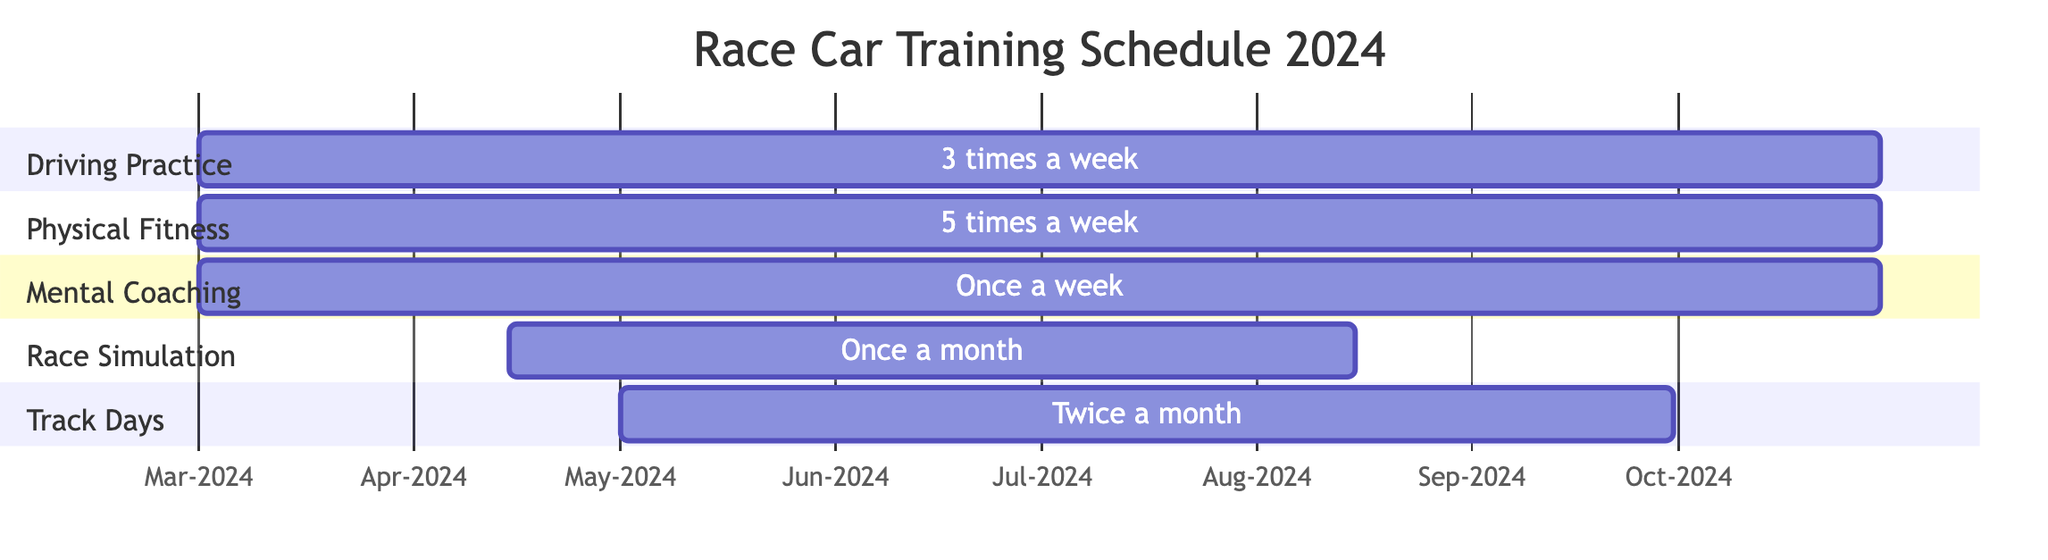What is the duration of the Driving Practice? The duration of Driving Practice is given in the diagram as 245 days. This is stated directly under the Driving Practice section.
Answer: 245 days How many times a week is Physical Fitness Training scheduled? The frequency of Physical Fitness Training is noted as 5 times a week in the diagram. This is clearly indicated in the section for Physical Fitness.
Answer: 5 times a week Which task starts latest? By comparing the start dates of all tasks listed in the chart, Race Simulation Events starts on 2024-04-15, which is later than the others that start on 2024-03-01.
Answer: Race Simulation Events What is the total number of tasks in the training schedule? There are five individual tasks presented in the Gantt Chart: Driving Practice, Physical Fitness Training, Mental Coaching Sessions, Race Simulation Events, and Track Days with Coaches. Counting these gives a total of five tasks.
Answer: 5 When do the Track Days with Coaches end? The end date for Track Days with Coaches is explicitly mentioned as 2024-09-30 in the section for Track Days.
Answer: 2024-09-30 How many days do Race Simulation Events occupy? The duration of Race Simulation Events is mentioned as 122 days in the diagram. This is calculated based on the start and end dates provided for Race Simulation.
Answer: 122 days What is the frequency of the Mental Coaching Sessions? The frequency for Mental Coaching Sessions is indicated as once a week in the diagram. This is stated directly under the Mental Coaching section.
Answer: once a week What is the overlap between Driving Practice and Physical Fitness Training? Both Driving Practice and Physical Fitness Training start on 2024-03-01 and end on 2024-10-30. Therefore, they fully overlap during this period.
Answer: full overlap How many months of Race Simulation Events are scheduled in the training program? The duration is from 2024-04-15 to 2024-08-15, which spans four months when calculated as a range.
Answer: 4 months 